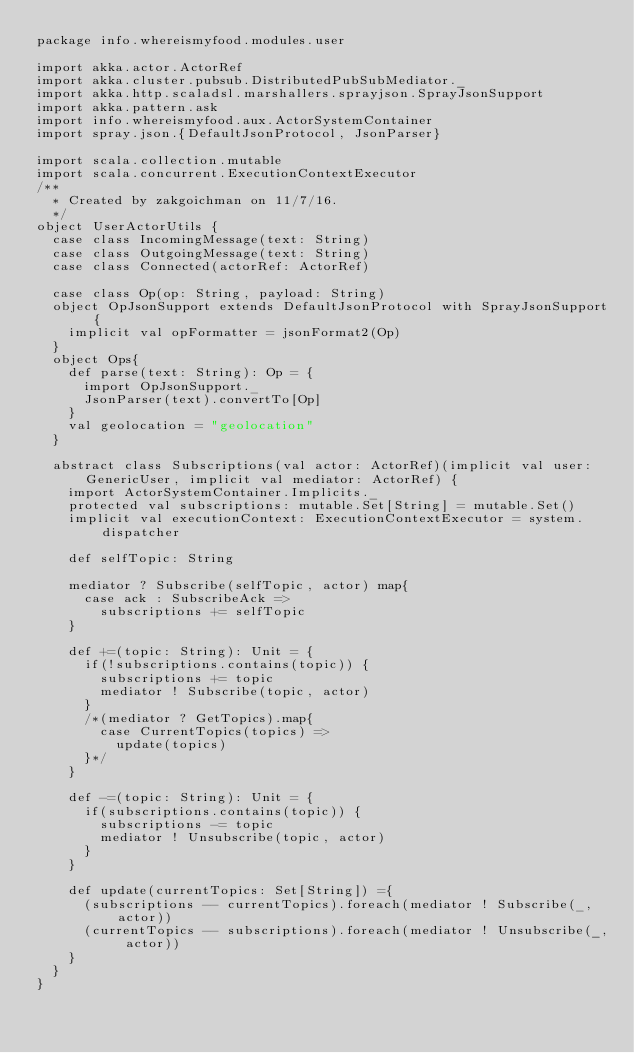<code> <loc_0><loc_0><loc_500><loc_500><_Scala_>package info.whereismyfood.modules.user

import akka.actor.ActorRef
import akka.cluster.pubsub.DistributedPubSubMediator._
import akka.http.scaladsl.marshallers.sprayjson.SprayJsonSupport
import akka.pattern.ask
import info.whereismyfood.aux.ActorSystemContainer
import spray.json.{DefaultJsonProtocol, JsonParser}

import scala.collection.mutable
import scala.concurrent.ExecutionContextExecutor
/**
  * Created by zakgoichman on 11/7/16.
  */
object UserActorUtils {
  case class IncomingMessage(text: String)
  case class OutgoingMessage(text: String)
  case class Connected(actorRef: ActorRef)

  case class Op(op: String, payload: String)
  object OpJsonSupport extends DefaultJsonProtocol with SprayJsonSupport {
    implicit val opFormatter = jsonFormat2(Op)
  }
  object Ops{
    def parse(text: String): Op = {
      import OpJsonSupport._
      JsonParser(text).convertTo[Op]
    }
    val geolocation = "geolocation"
  }

  abstract class Subscriptions(val actor: ActorRef)(implicit val user: GenericUser, implicit val mediator: ActorRef) {
    import ActorSystemContainer.Implicits._
    protected val subscriptions: mutable.Set[String] = mutable.Set()
    implicit val executionContext: ExecutionContextExecutor = system.dispatcher

    def selfTopic: String

    mediator ? Subscribe(selfTopic, actor) map{
      case ack : SubscribeAck =>
        subscriptions += selfTopic
    }

    def +=(topic: String): Unit = {
      if(!subscriptions.contains(topic)) {
        subscriptions += topic
        mediator ! Subscribe(topic, actor)
      }
      /*(mediator ? GetTopics).map{
        case CurrentTopics(topics) =>
          update(topics)
      }*/
    }

    def -=(topic: String): Unit = {
      if(subscriptions.contains(topic)) {
        subscriptions -= topic
        mediator ! Unsubscribe(topic, actor)
      }
    }

    def update(currentTopics: Set[String]) ={
      (subscriptions -- currentTopics).foreach(mediator ! Subscribe(_, actor))
      (currentTopics -- subscriptions).foreach(mediator ! Unsubscribe(_, actor))
    }
  }
}</code> 